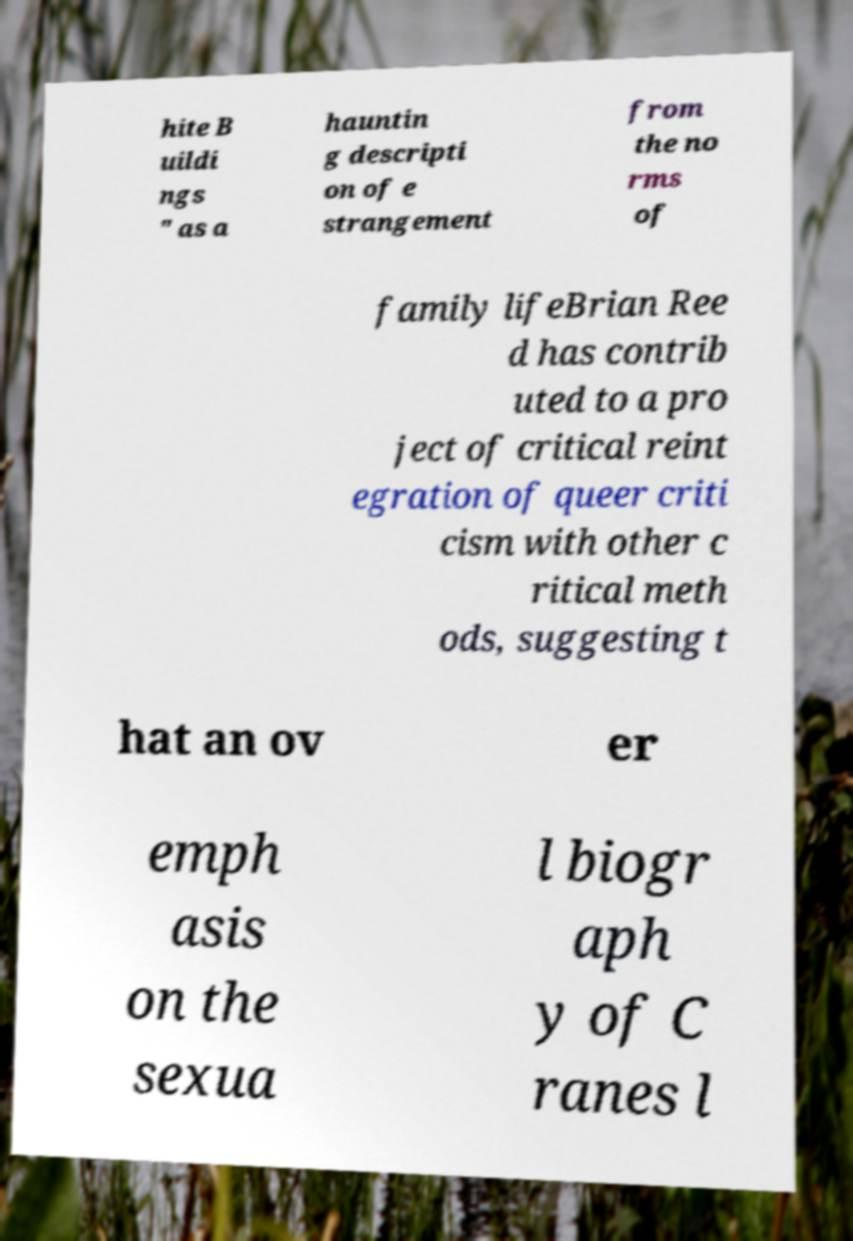Could you assist in decoding the text presented in this image and type it out clearly? hite B uildi ngs " as a hauntin g descripti on of e strangement from the no rms of family lifeBrian Ree d has contrib uted to a pro ject of critical reint egration of queer criti cism with other c ritical meth ods, suggesting t hat an ov er emph asis on the sexua l biogr aph y of C ranes l 